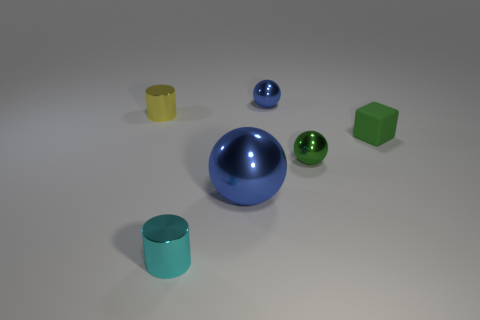What is the shape of the tiny green rubber thing right of the small shiny object behind the yellow thing?
Give a very brief answer. Cube. Do the sphere on the right side of the tiny blue ball and the cyan shiny cylinder in front of the tiny rubber object have the same size?
Your response must be concise. Yes. Are there any spheres that have the same material as the green block?
Keep it short and to the point. No. What is the size of the metallic sphere that is the same color as the small block?
Your answer should be very brief. Small. Are there any yellow metal cylinders behind the tiny blue metallic ball to the right of the tiny cylinder behind the small green metallic ball?
Your answer should be very brief. No. Are there any large blue shiny balls on the right side of the big sphere?
Offer a very short reply. No. There is a small metallic cylinder that is in front of the small green block; what number of metal cylinders are in front of it?
Provide a short and direct response. 0. There is a cyan shiny cylinder; is it the same size as the sphere on the left side of the tiny blue metal object?
Ensure brevity in your answer.  No. Are there any other small blocks that have the same color as the tiny rubber block?
Give a very brief answer. No. What is the size of the other green object that is made of the same material as the large object?
Provide a short and direct response. Small. 